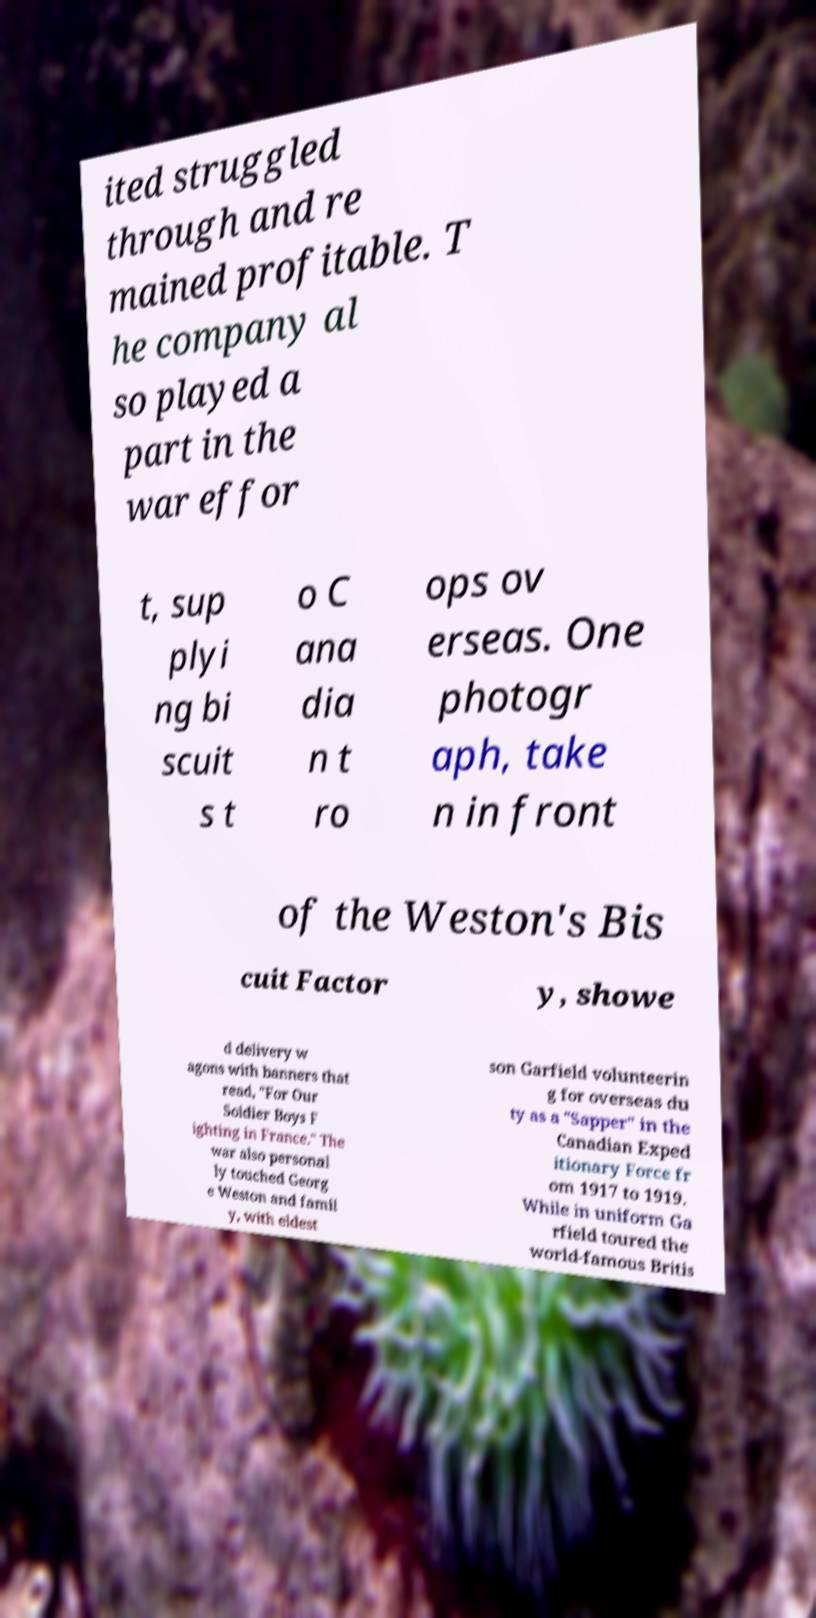I need the written content from this picture converted into text. Can you do that? ited struggled through and re mained profitable. T he company al so played a part in the war effor t, sup plyi ng bi scuit s t o C ana dia n t ro ops ov erseas. One photogr aph, take n in front of the Weston's Bis cuit Factor y, showe d delivery w agons with banners that read, "For Our Soldier Boys F ighting in France." The war also personal ly touched Georg e Weston and famil y, with eldest son Garfield volunteerin g for overseas du ty as a "Sapper" in the Canadian Exped itionary Force fr om 1917 to 1919. While in uniform Ga rfield toured the world-famous Britis 